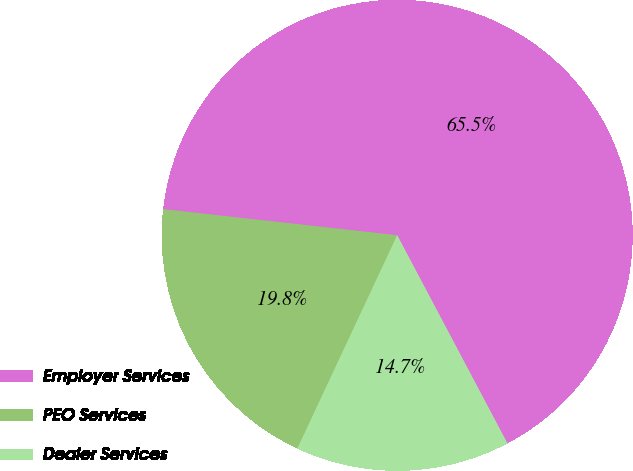Convert chart. <chart><loc_0><loc_0><loc_500><loc_500><pie_chart><fcel>Employer Services<fcel>PEO Services<fcel>Dealer Services<nl><fcel>65.48%<fcel>19.8%<fcel>14.72%<nl></chart> 